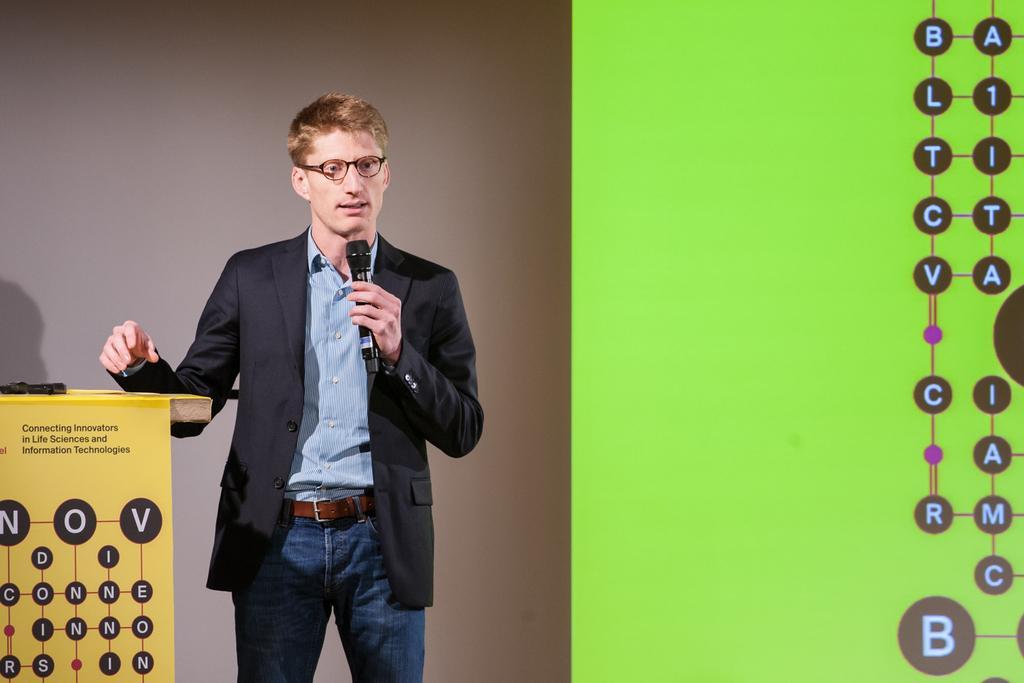How would you summarize this image in a sentence or two? In this image there is a man standing in the center holding a mic in his hand. On the left side there is a podium with some text written on it. On the right side there is a screen which is green in colour and there is some text on the screen. 